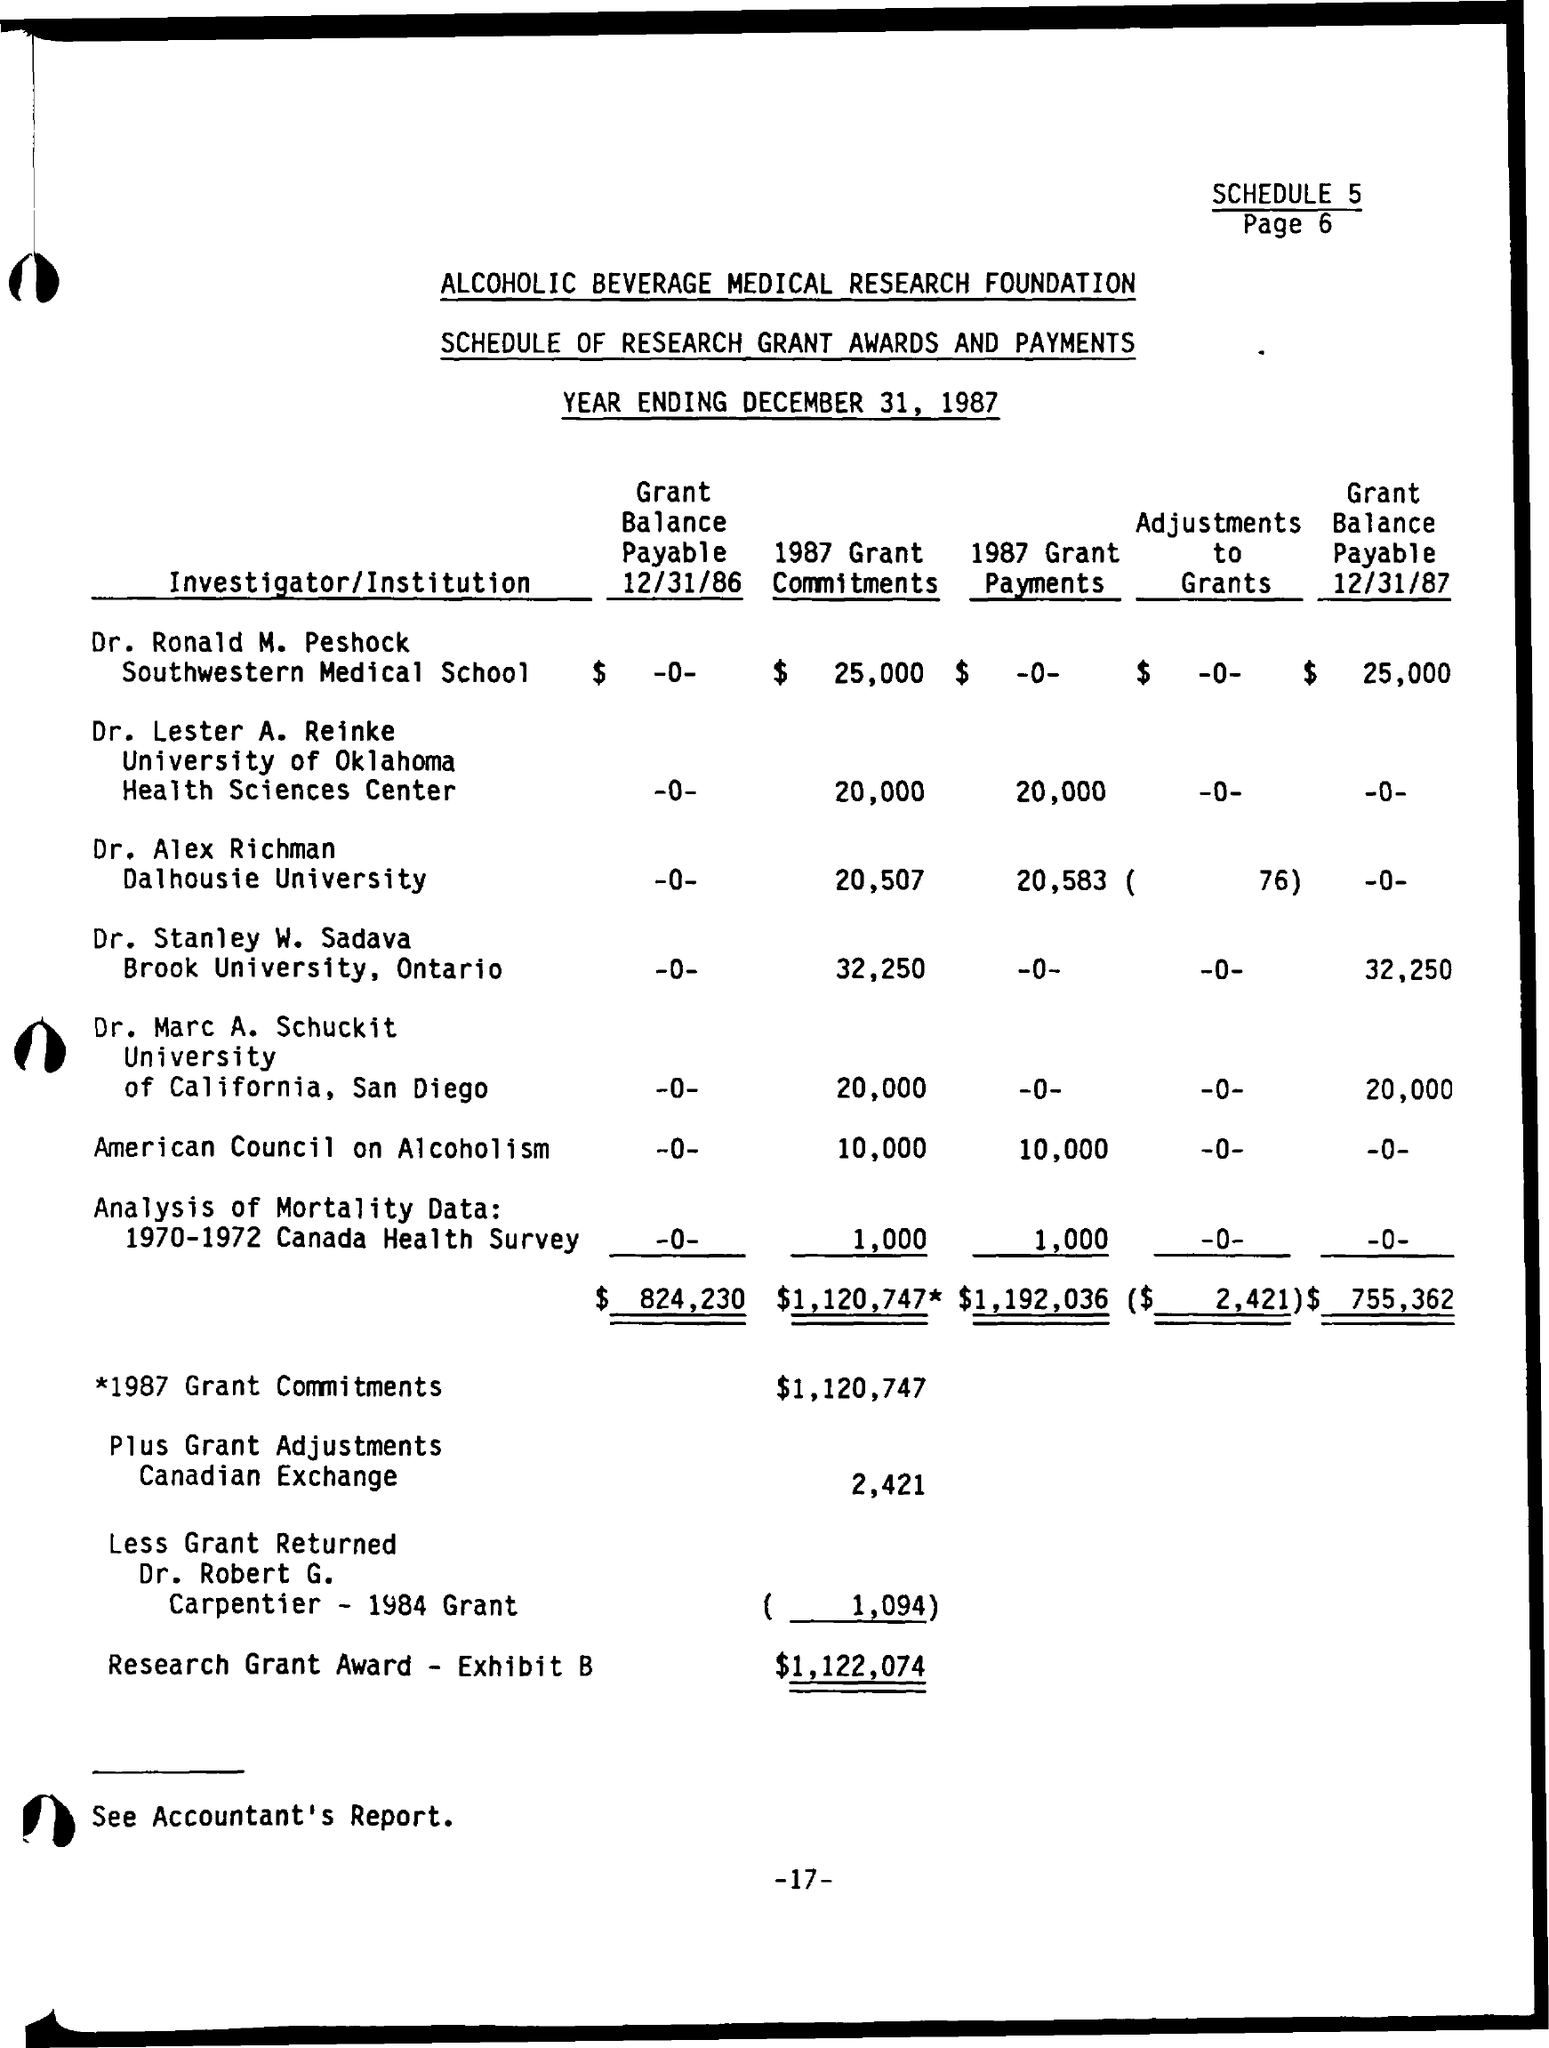What is the name of the foundation as mentioned in the given page ?
Ensure brevity in your answer.  Alcoholic Beverage Medical Research Foundation. What is the year ending date mentioned in the given page ?
Provide a succinct answer. December 31, 1987. Dr. Alex Richman belongs to which institution ?
Offer a terse response. Dalhousie university. What is the grant balance payable on 12/31/87 for dr. stanley w. sadava ?
Your response must be concise. 32,250. What is the total grant balance payable on 12/31/86 as shown in the page ?
Offer a very short reply. $824,230. What is the total amount of adjustments to grants as shown in the given page ?
Offer a very short reply. 2,421. What is the amount of 1987 grant commitments mentioned in the given page ?
Your response must be concise. $ 1,120,747. 